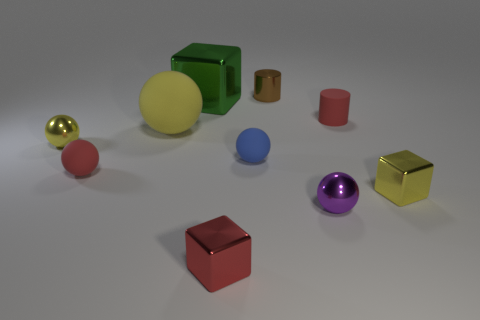Are there an equal number of metal cylinders in front of the green object and yellow blocks?
Give a very brief answer. No. Are there any yellow metallic things right of the big object in front of the cylinder that is in front of the large block?
Offer a very short reply. Yes. What is the material of the small yellow sphere?
Make the answer very short. Metal. What number of other objects are the same shape as the small purple thing?
Keep it short and to the point. 4. Is the shape of the green metal thing the same as the red metallic thing?
Offer a very short reply. Yes. What number of things are rubber things that are to the left of the tiny red cylinder or tiny shiny objects to the right of the tiny brown object?
Provide a short and direct response. 5. How many objects are small red shiny things or gray matte balls?
Your response must be concise. 1. There is a yellow shiny thing that is in front of the red rubber ball; what number of tiny brown shiny cylinders are to the right of it?
Offer a terse response. 0. What number of other things are the same size as the purple sphere?
Ensure brevity in your answer.  7. There is a cube that is the same color as the large rubber thing; what size is it?
Offer a very short reply. Small. 